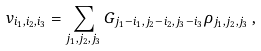<formula> <loc_0><loc_0><loc_500><loc_500>v _ { i _ { 1 } , i _ { 2 } , i _ { 3 } } = \sum _ { j _ { 1 } , j _ { 2 } , j _ { 3 } } G _ { j _ { 1 } - i _ { 1 } , j _ { 2 } - i _ { 2 } , j _ { 3 } - i _ { 3 } } \rho _ { j _ { 1 } , j _ { 2 } , j _ { 3 } } \, ,</formula> 